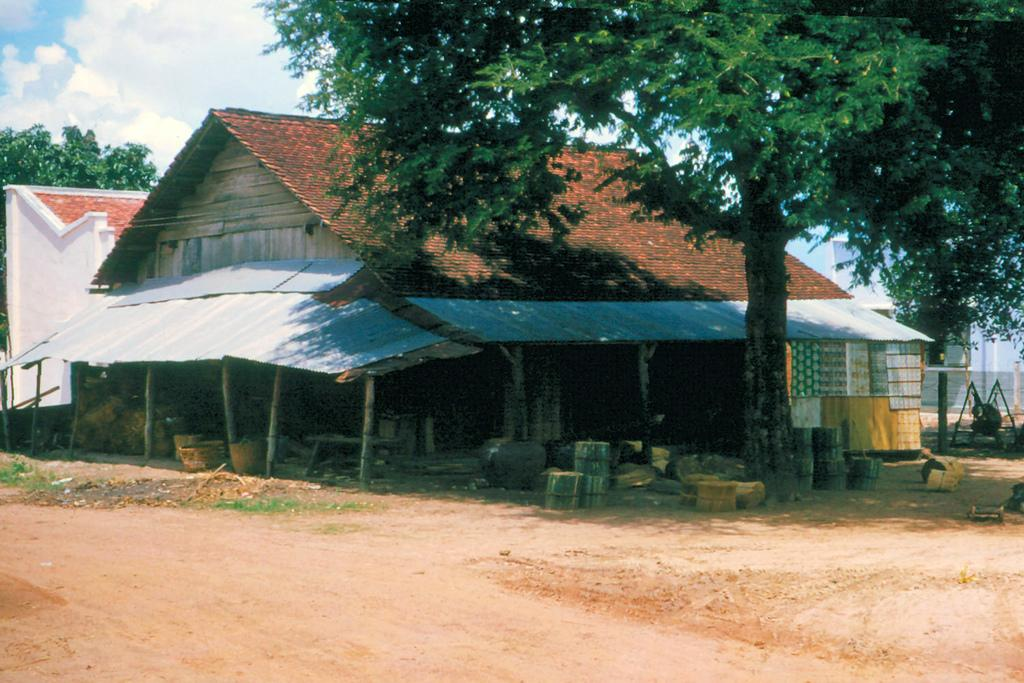What type of structure is in the image? There is a small shed house in the image. What color is the roof of the shed house? The roof of the shed house has a brown color. What is in front of the shed house? There is a ground in front of the shed house. What can be seen on the right side of the image? There is a huge tree and clay pots on the right side of the image. What route does the heart take to reach the shed house in the image? There is no heart or route present in the image; it only features a small shed house, a brown roof, a ground, a huge tree, and clay pots. 